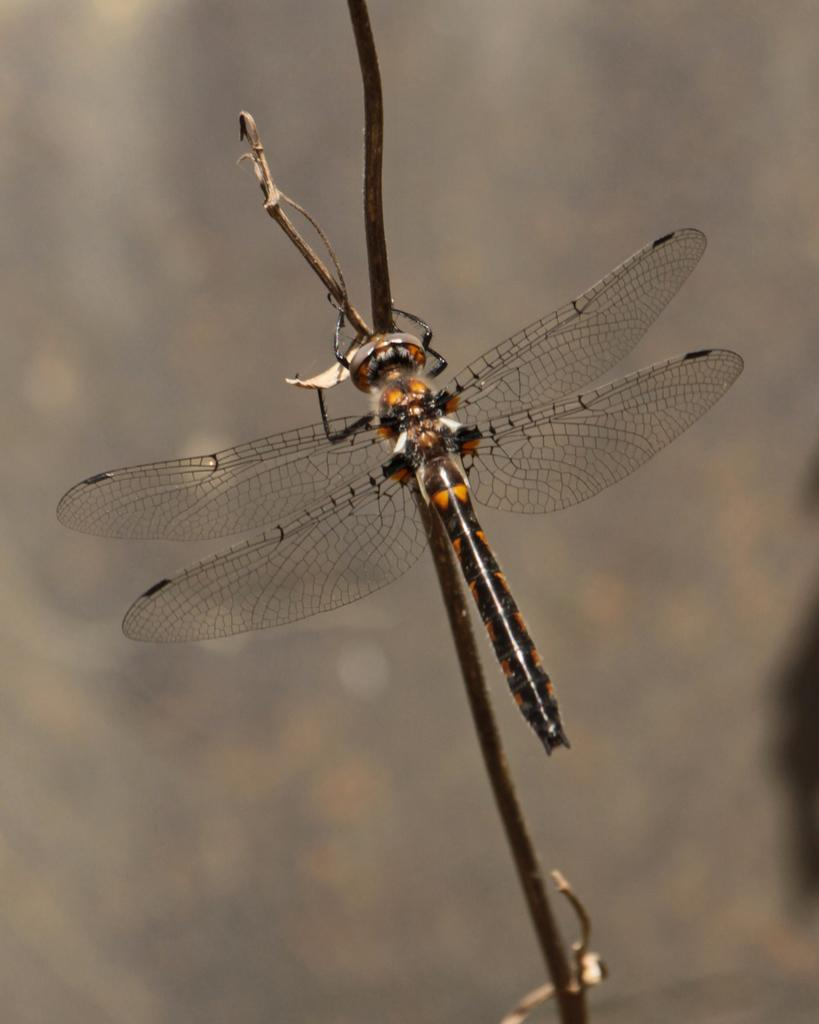What is the main subject of the image? There is a dragonfly in the image. Where is the dragonfly located? The dragonfly is on a stem. Can you describe the background of the image? The background of the image is blurred. What type of silverware is visible in the image? There is no silverware present in the image; it features a dragonfly on a stem with a blurred background. 